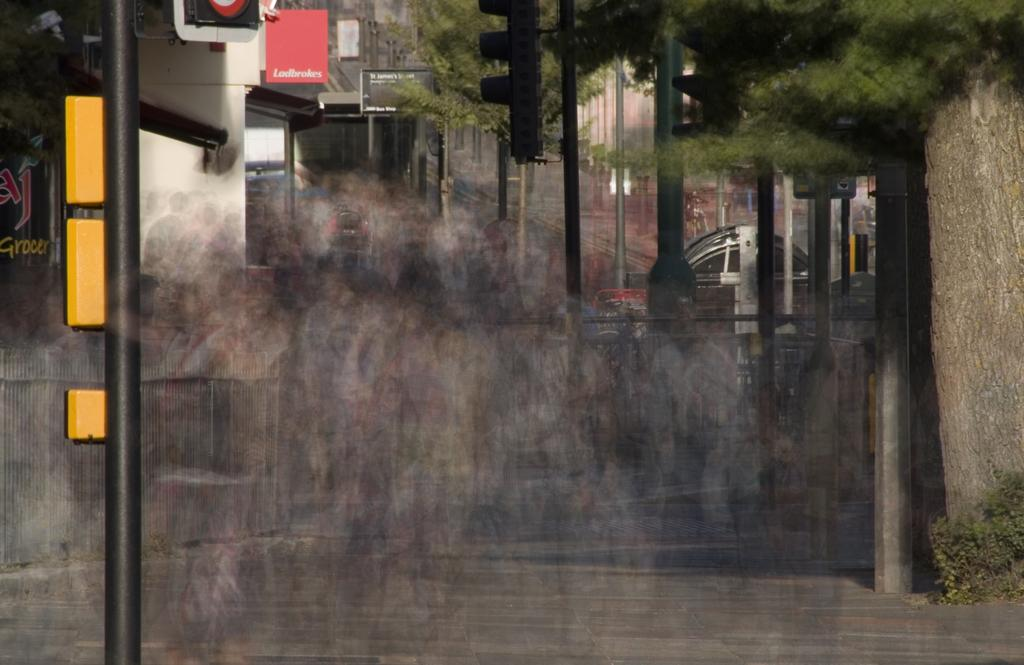What structures are present in the image? There are poles and name boards in the image. What type of vegetation can be seen in the image? There are trees in the image. What else is visible in the image? There is a vehicle in the image. Can you see any mountains in the image? There are no mountains visible in the image. Are there any pigs present in the image? There are no pigs present in the image. 